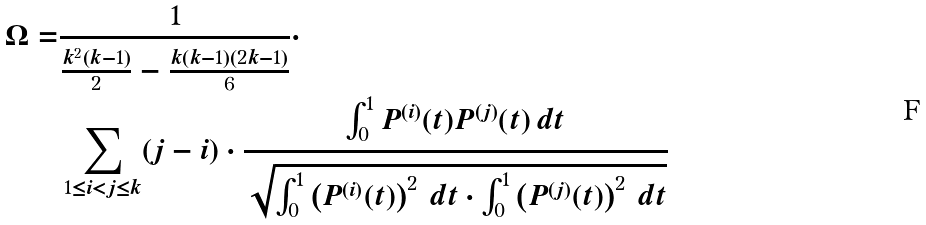Convert formula to latex. <formula><loc_0><loc_0><loc_500><loc_500>\Omega = & \frac { 1 } { \frac { k ^ { 2 } ( k - 1 ) } { 2 } - \frac { k ( k - 1 ) ( 2 k - 1 ) } { 6 } } \cdot \\ & \sum _ { 1 \leq i < j \leq k } ( j - i ) \cdot \frac { \int _ { 0 } ^ { 1 } P ^ { ( i ) } ( t ) P ^ { ( j ) } ( t ) \, d t } { \sqrt { \int _ { 0 } ^ { 1 } \left ( P ^ { ( i ) } ( t ) \right ) ^ { 2 } \, d t \cdot \int _ { 0 } ^ { 1 } \left ( P ^ { ( j ) } ( t ) \right ) ^ { 2 } \, d t } }</formula> 